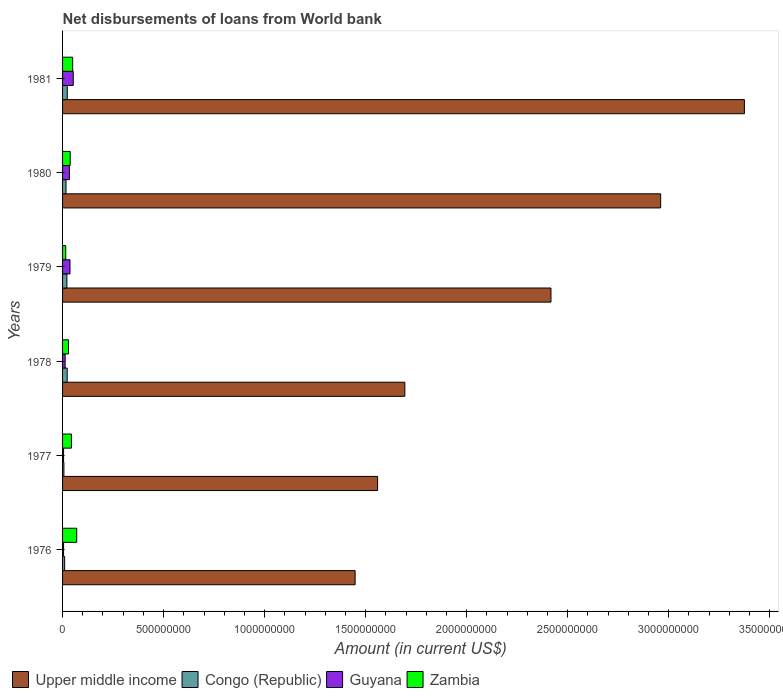How many different coloured bars are there?
Ensure brevity in your answer.  4. How many groups of bars are there?
Offer a terse response. 6. Are the number of bars per tick equal to the number of legend labels?
Your response must be concise. Yes. Are the number of bars on each tick of the Y-axis equal?
Keep it short and to the point. Yes. How many bars are there on the 5th tick from the bottom?
Offer a terse response. 4. What is the label of the 2nd group of bars from the top?
Provide a short and direct response. 1980. In how many cases, is the number of bars for a given year not equal to the number of legend labels?
Provide a succinct answer. 0. What is the amount of loan disbursed from World Bank in Upper middle income in 1977?
Offer a very short reply. 1.56e+09. Across all years, what is the maximum amount of loan disbursed from World Bank in Upper middle income?
Give a very brief answer. 3.37e+09. Across all years, what is the minimum amount of loan disbursed from World Bank in Zambia?
Your answer should be very brief. 1.57e+07. In which year was the amount of loan disbursed from World Bank in Zambia minimum?
Your answer should be compact. 1979. What is the total amount of loan disbursed from World Bank in Guyana in the graph?
Offer a very short reply. 1.46e+08. What is the difference between the amount of loan disbursed from World Bank in Upper middle income in 1976 and that in 1980?
Your answer should be very brief. -1.51e+09. What is the difference between the amount of loan disbursed from World Bank in Congo (Republic) in 1979 and the amount of loan disbursed from World Bank in Zambia in 1978?
Keep it short and to the point. -7.86e+06. What is the average amount of loan disbursed from World Bank in Zambia per year?
Keep it short and to the point. 4.11e+07. In the year 1978, what is the difference between the amount of loan disbursed from World Bank in Congo (Republic) and amount of loan disbursed from World Bank in Upper middle income?
Your answer should be very brief. -1.67e+09. In how many years, is the amount of loan disbursed from World Bank in Zambia greater than 2200000000 US$?
Make the answer very short. 0. What is the ratio of the amount of loan disbursed from World Bank in Congo (Republic) in 1977 to that in 1980?
Keep it short and to the point. 0.39. What is the difference between the highest and the second highest amount of loan disbursed from World Bank in Zambia?
Offer a very short reply. 2.00e+07. What is the difference between the highest and the lowest amount of loan disbursed from World Bank in Congo (Republic)?
Make the answer very short. 1.67e+07. In how many years, is the amount of loan disbursed from World Bank in Guyana greater than the average amount of loan disbursed from World Bank in Guyana taken over all years?
Offer a terse response. 3. Is it the case that in every year, the sum of the amount of loan disbursed from World Bank in Congo (Republic) and amount of loan disbursed from World Bank in Upper middle income is greater than the sum of amount of loan disbursed from World Bank in Guyana and amount of loan disbursed from World Bank in Zambia?
Your answer should be compact. No. What does the 4th bar from the top in 1981 represents?
Provide a short and direct response. Upper middle income. What does the 3rd bar from the bottom in 1979 represents?
Keep it short and to the point. Guyana. Is it the case that in every year, the sum of the amount of loan disbursed from World Bank in Zambia and amount of loan disbursed from World Bank in Congo (Republic) is greater than the amount of loan disbursed from World Bank in Guyana?
Provide a succinct answer. Yes. Does the graph contain any zero values?
Provide a short and direct response. No. Does the graph contain grids?
Your answer should be very brief. No. What is the title of the graph?
Provide a succinct answer. Net disbursements of loans from World bank. Does "Low income" appear as one of the legend labels in the graph?
Keep it short and to the point. No. What is the Amount (in current US$) in Upper middle income in 1976?
Provide a succinct answer. 1.45e+09. What is the Amount (in current US$) of Congo (Republic) in 1976?
Provide a short and direct response. 1.02e+07. What is the Amount (in current US$) in Guyana in 1976?
Give a very brief answer. 5.01e+06. What is the Amount (in current US$) of Zambia in 1976?
Make the answer very short. 7.00e+07. What is the Amount (in current US$) in Upper middle income in 1977?
Give a very brief answer. 1.56e+09. What is the Amount (in current US$) of Congo (Republic) in 1977?
Give a very brief answer. 6.67e+06. What is the Amount (in current US$) of Guyana in 1977?
Make the answer very short. 5.03e+06. What is the Amount (in current US$) in Zambia in 1977?
Make the answer very short. 4.40e+07. What is the Amount (in current US$) in Upper middle income in 1978?
Make the answer very short. 1.69e+09. What is the Amount (in current US$) of Congo (Republic) in 1978?
Offer a very short reply. 2.30e+07. What is the Amount (in current US$) of Guyana in 1978?
Your response must be concise. 1.28e+07. What is the Amount (in current US$) of Zambia in 1978?
Give a very brief answer. 2.93e+07. What is the Amount (in current US$) of Upper middle income in 1979?
Your answer should be compact. 2.42e+09. What is the Amount (in current US$) in Congo (Republic) in 1979?
Your answer should be very brief. 2.14e+07. What is the Amount (in current US$) in Guyana in 1979?
Ensure brevity in your answer.  3.68e+07. What is the Amount (in current US$) in Zambia in 1979?
Offer a terse response. 1.57e+07. What is the Amount (in current US$) in Upper middle income in 1980?
Give a very brief answer. 2.96e+09. What is the Amount (in current US$) in Congo (Republic) in 1980?
Your answer should be very brief. 1.71e+07. What is the Amount (in current US$) of Guyana in 1980?
Your answer should be very brief. 3.38e+07. What is the Amount (in current US$) of Zambia in 1980?
Ensure brevity in your answer.  3.78e+07. What is the Amount (in current US$) in Upper middle income in 1981?
Offer a very short reply. 3.37e+09. What is the Amount (in current US$) in Congo (Republic) in 1981?
Your response must be concise. 2.34e+07. What is the Amount (in current US$) of Guyana in 1981?
Give a very brief answer. 5.28e+07. What is the Amount (in current US$) of Zambia in 1981?
Your response must be concise. 5.00e+07. Across all years, what is the maximum Amount (in current US$) of Upper middle income?
Ensure brevity in your answer.  3.37e+09. Across all years, what is the maximum Amount (in current US$) of Congo (Republic)?
Offer a terse response. 2.34e+07. Across all years, what is the maximum Amount (in current US$) of Guyana?
Your answer should be very brief. 5.28e+07. Across all years, what is the maximum Amount (in current US$) in Zambia?
Make the answer very short. 7.00e+07. Across all years, what is the minimum Amount (in current US$) in Upper middle income?
Your answer should be compact. 1.45e+09. Across all years, what is the minimum Amount (in current US$) of Congo (Republic)?
Ensure brevity in your answer.  6.67e+06. Across all years, what is the minimum Amount (in current US$) in Guyana?
Offer a very short reply. 5.01e+06. Across all years, what is the minimum Amount (in current US$) in Zambia?
Give a very brief answer. 1.57e+07. What is the total Amount (in current US$) of Upper middle income in the graph?
Keep it short and to the point. 1.35e+1. What is the total Amount (in current US$) in Congo (Republic) in the graph?
Provide a short and direct response. 1.02e+08. What is the total Amount (in current US$) of Guyana in the graph?
Your answer should be very brief. 1.46e+08. What is the total Amount (in current US$) of Zambia in the graph?
Offer a very short reply. 2.47e+08. What is the difference between the Amount (in current US$) in Upper middle income in 1976 and that in 1977?
Make the answer very short. -1.11e+08. What is the difference between the Amount (in current US$) of Congo (Republic) in 1976 and that in 1977?
Provide a short and direct response. 3.58e+06. What is the difference between the Amount (in current US$) in Guyana in 1976 and that in 1977?
Offer a very short reply. -1.40e+04. What is the difference between the Amount (in current US$) in Zambia in 1976 and that in 1977?
Offer a terse response. 2.61e+07. What is the difference between the Amount (in current US$) of Upper middle income in 1976 and that in 1978?
Offer a very short reply. -2.46e+08. What is the difference between the Amount (in current US$) in Congo (Republic) in 1976 and that in 1978?
Give a very brief answer. -1.27e+07. What is the difference between the Amount (in current US$) in Guyana in 1976 and that in 1978?
Provide a short and direct response. -7.83e+06. What is the difference between the Amount (in current US$) in Zambia in 1976 and that in 1978?
Your response must be concise. 4.07e+07. What is the difference between the Amount (in current US$) in Upper middle income in 1976 and that in 1979?
Make the answer very short. -9.69e+08. What is the difference between the Amount (in current US$) of Congo (Republic) in 1976 and that in 1979?
Provide a succinct answer. -1.12e+07. What is the difference between the Amount (in current US$) in Guyana in 1976 and that in 1979?
Give a very brief answer. -3.18e+07. What is the difference between the Amount (in current US$) of Zambia in 1976 and that in 1979?
Your answer should be very brief. 5.44e+07. What is the difference between the Amount (in current US$) of Upper middle income in 1976 and that in 1980?
Offer a very short reply. -1.51e+09. What is the difference between the Amount (in current US$) in Congo (Republic) in 1976 and that in 1980?
Offer a very short reply. -6.86e+06. What is the difference between the Amount (in current US$) of Guyana in 1976 and that in 1980?
Provide a short and direct response. -2.88e+07. What is the difference between the Amount (in current US$) in Zambia in 1976 and that in 1980?
Keep it short and to the point. 3.22e+07. What is the difference between the Amount (in current US$) of Upper middle income in 1976 and that in 1981?
Provide a short and direct response. -1.93e+09. What is the difference between the Amount (in current US$) of Congo (Republic) in 1976 and that in 1981?
Give a very brief answer. -1.31e+07. What is the difference between the Amount (in current US$) in Guyana in 1976 and that in 1981?
Your answer should be very brief. -4.78e+07. What is the difference between the Amount (in current US$) in Zambia in 1976 and that in 1981?
Provide a succinct answer. 2.00e+07. What is the difference between the Amount (in current US$) in Upper middle income in 1977 and that in 1978?
Ensure brevity in your answer.  -1.35e+08. What is the difference between the Amount (in current US$) of Congo (Republic) in 1977 and that in 1978?
Your answer should be compact. -1.63e+07. What is the difference between the Amount (in current US$) of Guyana in 1977 and that in 1978?
Make the answer very short. -7.82e+06. What is the difference between the Amount (in current US$) of Zambia in 1977 and that in 1978?
Keep it short and to the point. 1.47e+07. What is the difference between the Amount (in current US$) of Upper middle income in 1977 and that in 1979?
Ensure brevity in your answer.  -8.58e+08. What is the difference between the Amount (in current US$) in Congo (Republic) in 1977 and that in 1979?
Make the answer very short. -1.48e+07. What is the difference between the Amount (in current US$) in Guyana in 1977 and that in 1979?
Keep it short and to the point. -3.18e+07. What is the difference between the Amount (in current US$) of Zambia in 1977 and that in 1979?
Give a very brief answer. 2.83e+07. What is the difference between the Amount (in current US$) in Upper middle income in 1977 and that in 1980?
Keep it short and to the point. -1.40e+09. What is the difference between the Amount (in current US$) of Congo (Republic) in 1977 and that in 1980?
Offer a very short reply. -1.04e+07. What is the difference between the Amount (in current US$) of Guyana in 1977 and that in 1980?
Make the answer very short. -2.88e+07. What is the difference between the Amount (in current US$) of Zambia in 1977 and that in 1980?
Your response must be concise. 6.12e+06. What is the difference between the Amount (in current US$) in Upper middle income in 1977 and that in 1981?
Give a very brief answer. -1.82e+09. What is the difference between the Amount (in current US$) of Congo (Republic) in 1977 and that in 1981?
Your answer should be very brief. -1.67e+07. What is the difference between the Amount (in current US$) of Guyana in 1977 and that in 1981?
Keep it short and to the point. -4.78e+07. What is the difference between the Amount (in current US$) in Zambia in 1977 and that in 1981?
Your answer should be very brief. -6.10e+06. What is the difference between the Amount (in current US$) of Upper middle income in 1978 and that in 1979?
Provide a succinct answer. -7.23e+08. What is the difference between the Amount (in current US$) of Congo (Republic) in 1978 and that in 1979?
Ensure brevity in your answer.  1.52e+06. What is the difference between the Amount (in current US$) of Guyana in 1978 and that in 1979?
Offer a very short reply. -2.40e+07. What is the difference between the Amount (in current US$) of Zambia in 1978 and that in 1979?
Provide a succinct answer. 1.36e+07. What is the difference between the Amount (in current US$) in Upper middle income in 1978 and that in 1980?
Ensure brevity in your answer.  -1.27e+09. What is the difference between the Amount (in current US$) in Congo (Republic) in 1978 and that in 1980?
Make the answer very short. 5.85e+06. What is the difference between the Amount (in current US$) in Guyana in 1978 and that in 1980?
Your response must be concise. -2.10e+07. What is the difference between the Amount (in current US$) of Zambia in 1978 and that in 1980?
Offer a very short reply. -8.54e+06. What is the difference between the Amount (in current US$) of Upper middle income in 1978 and that in 1981?
Ensure brevity in your answer.  -1.68e+09. What is the difference between the Amount (in current US$) of Congo (Republic) in 1978 and that in 1981?
Make the answer very short. -3.97e+05. What is the difference between the Amount (in current US$) of Guyana in 1978 and that in 1981?
Your answer should be very brief. -4.00e+07. What is the difference between the Amount (in current US$) of Zambia in 1978 and that in 1981?
Provide a short and direct response. -2.07e+07. What is the difference between the Amount (in current US$) of Upper middle income in 1979 and that in 1980?
Keep it short and to the point. -5.43e+08. What is the difference between the Amount (in current US$) in Congo (Republic) in 1979 and that in 1980?
Offer a very short reply. 4.34e+06. What is the difference between the Amount (in current US$) of Guyana in 1979 and that in 1980?
Provide a short and direct response. 3.01e+06. What is the difference between the Amount (in current US$) of Zambia in 1979 and that in 1980?
Ensure brevity in your answer.  -2.22e+07. What is the difference between the Amount (in current US$) in Upper middle income in 1979 and that in 1981?
Ensure brevity in your answer.  -9.57e+08. What is the difference between the Amount (in current US$) in Congo (Republic) in 1979 and that in 1981?
Make the answer very short. -1.91e+06. What is the difference between the Amount (in current US$) of Guyana in 1979 and that in 1981?
Keep it short and to the point. -1.60e+07. What is the difference between the Amount (in current US$) of Zambia in 1979 and that in 1981?
Your answer should be compact. -3.44e+07. What is the difference between the Amount (in current US$) of Upper middle income in 1980 and that in 1981?
Give a very brief answer. -4.14e+08. What is the difference between the Amount (in current US$) of Congo (Republic) in 1980 and that in 1981?
Your answer should be very brief. -6.25e+06. What is the difference between the Amount (in current US$) of Guyana in 1980 and that in 1981?
Offer a very short reply. -1.90e+07. What is the difference between the Amount (in current US$) in Zambia in 1980 and that in 1981?
Provide a succinct answer. -1.22e+07. What is the difference between the Amount (in current US$) in Upper middle income in 1976 and the Amount (in current US$) in Congo (Republic) in 1977?
Ensure brevity in your answer.  1.44e+09. What is the difference between the Amount (in current US$) of Upper middle income in 1976 and the Amount (in current US$) of Guyana in 1977?
Offer a terse response. 1.44e+09. What is the difference between the Amount (in current US$) of Upper middle income in 1976 and the Amount (in current US$) of Zambia in 1977?
Offer a very short reply. 1.40e+09. What is the difference between the Amount (in current US$) of Congo (Republic) in 1976 and the Amount (in current US$) of Guyana in 1977?
Make the answer very short. 5.22e+06. What is the difference between the Amount (in current US$) in Congo (Republic) in 1976 and the Amount (in current US$) in Zambia in 1977?
Provide a short and direct response. -3.37e+07. What is the difference between the Amount (in current US$) of Guyana in 1976 and the Amount (in current US$) of Zambia in 1977?
Give a very brief answer. -3.89e+07. What is the difference between the Amount (in current US$) of Upper middle income in 1976 and the Amount (in current US$) of Congo (Republic) in 1978?
Your response must be concise. 1.42e+09. What is the difference between the Amount (in current US$) in Upper middle income in 1976 and the Amount (in current US$) in Guyana in 1978?
Offer a terse response. 1.43e+09. What is the difference between the Amount (in current US$) in Upper middle income in 1976 and the Amount (in current US$) in Zambia in 1978?
Offer a very short reply. 1.42e+09. What is the difference between the Amount (in current US$) in Congo (Republic) in 1976 and the Amount (in current US$) in Guyana in 1978?
Your response must be concise. -2.60e+06. What is the difference between the Amount (in current US$) of Congo (Republic) in 1976 and the Amount (in current US$) of Zambia in 1978?
Keep it short and to the point. -1.91e+07. What is the difference between the Amount (in current US$) of Guyana in 1976 and the Amount (in current US$) of Zambia in 1978?
Provide a succinct answer. -2.43e+07. What is the difference between the Amount (in current US$) of Upper middle income in 1976 and the Amount (in current US$) of Congo (Republic) in 1979?
Offer a terse response. 1.43e+09. What is the difference between the Amount (in current US$) in Upper middle income in 1976 and the Amount (in current US$) in Guyana in 1979?
Offer a very short reply. 1.41e+09. What is the difference between the Amount (in current US$) in Upper middle income in 1976 and the Amount (in current US$) in Zambia in 1979?
Your answer should be very brief. 1.43e+09. What is the difference between the Amount (in current US$) of Congo (Republic) in 1976 and the Amount (in current US$) of Guyana in 1979?
Offer a terse response. -2.66e+07. What is the difference between the Amount (in current US$) in Congo (Republic) in 1976 and the Amount (in current US$) in Zambia in 1979?
Ensure brevity in your answer.  -5.43e+06. What is the difference between the Amount (in current US$) of Guyana in 1976 and the Amount (in current US$) of Zambia in 1979?
Provide a short and direct response. -1.07e+07. What is the difference between the Amount (in current US$) in Upper middle income in 1976 and the Amount (in current US$) in Congo (Republic) in 1980?
Your answer should be compact. 1.43e+09. What is the difference between the Amount (in current US$) in Upper middle income in 1976 and the Amount (in current US$) in Guyana in 1980?
Offer a terse response. 1.41e+09. What is the difference between the Amount (in current US$) of Upper middle income in 1976 and the Amount (in current US$) of Zambia in 1980?
Offer a terse response. 1.41e+09. What is the difference between the Amount (in current US$) of Congo (Republic) in 1976 and the Amount (in current US$) of Guyana in 1980?
Your response must be concise. -2.36e+07. What is the difference between the Amount (in current US$) of Congo (Republic) in 1976 and the Amount (in current US$) of Zambia in 1980?
Provide a succinct answer. -2.76e+07. What is the difference between the Amount (in current US$) of Guyana in 1976 and the Amount (in current US$) of Zambia in 1980?
Offer a terse response. -3.28e+07. What is the difference between the Amount (in current US$) in Upper middle income in 1976 and the Amount (in current US$) in Congo (Republic) in 1981?
Offer a very short reply. 1.42e+09. What is the difference between the Amount (in current US$) in Upper middle income in 1976 and the Amount (in current US$) in Guyana in 1981?
Keep it short and to the point. 1.39e+09. What is the difference between the Amount (in current US$) of Upper middle income in 1976 and the Amount (in current US$) of Zambia in 1981?
Offer a very short reply. 1.40e+09. What is the difference between the Amount (in current US$) of Congo (Republic) in 1976 and the Amount (in current US$) of Guyana in 1981?
Ensure brevity in your answer.  -4.26e+07. What is the difference between the Amount (in current US$) in Congo (Republic) in 1976 and the Amount (in current US$) in Zambia in 1981?
Provide a succinct answer. -3.98e+07. What is the difference between the Amount (in current US$) in Guyana in 1976 and the Amount (in current US$) in Zambia in 1981?
Provide a succinct answer. -4.50e+07. What is the difference between the Amount (in current US$) of Upper middle income in 1977 and the Amount (in current US$) of Congo (Republic) in 1978?
Keep it short and to the point. 1.54e+09. What is the difference between the Amount (in current US$) in Upper middle income in 1977 and the Amount (in current US$) in Guyana in 1978?
Provide a short and direct response. 1.55e+09. What is the difference between the Amount (in current US$) in Upper middle income in 1977 and the Amount (in current US$) in Zambia in 1978?
Your answer should be very brief. 1.53e+09. What is the difference between the Amount (in current US$) in Congo (Republic) in 1977 and the Amount (in current US$) in Guyana in 1978?
Make the answer very short. -6.18e+06. What is the difference between the Amount (in current US$) in Congo (Republic) in 1977 and the Amount (in current US$) in Zambia in 1978?
Your response must be concise. -2.26e+07. What is the difference between the Amount (in current US$) of Guyana in 1977 and the Amount (in current US$) of Zambia in 1978?
Offer a terse response. -2.43e+07. What is the difference between the Amount (in current US$) of Upper middle income in 1977 and the Amount (in current US$) of Congo (Republic) in 1979?
Offer a terse response. 1.54e+09. What is the difference between the Amount (in current US$) of Upper middle income in 1977 and the Amount (in current US$) of Guyana in 1979?
Provide a short and direct response. 1.52e+09. What is the difference between the Amount (in current US$) in Upper middle income in 1977 and the Amount (in current US$) in Zambia in 1979?
Provide a succinct answer. 1.54e+09. What is the difference between the Amount (in current US$) of Congo (Republic) in 1977 and the Amount (in current US$) of Guyana in 1979?
Offer a terse response. -3.02e+07. What is the difference between the Amount (in current US$) of Congo (Republic) in 1977 and the Amount (in current US$) of Zambia in 1979?
Give a very brief answer. -9.01e+06. What is the difference between the Amount (in current US$) of Guyana in 1977 and the Amount (in current US$) of Zambia in 1979?
Make the answer very short. -1.06e+07. What is the difference between the Amount (in current US$) of Upper middle income in 1977 and the Amount (in current US$) of Congo (Republic) in 1980?
Your answer should be very brief. 1.54e+09. What is the difference between the Amount (in current US$) in Upper middle income in 1977 and the Amount (in current US$) in Guyana in 1980?
Offer a very short reply. 1.53e+09. What is the difference between the Amount (in current US$) in Upper middle income in 1977 and the Amount (in current US$) in Zambia in 1980?
Provide a succinct answer. 1.52e+09. What is the difference between the Amount (in current US$) in Congo (Republic) in 1977 and the Amount (in current US$) in Guyana in 1980?
Your response must be concise. -2.71e+07. What is the difference between the Amount (in current US$) of Congo (Republic) in 1977 and the Amount (in current US$) of Zambia in 1980?
Make the answer very short. -3.12e+07. What is the difference between the Amount (in current US$) of Guyana in 1977 and the Amount (in current US$) of Zambia in 1980?
Make the answer very short. -3.28e+07. What is the difference between the Amount (in current US$) in Upper middle income in 1977 and the Amount (in current US$) in Congo (Republic) in 1981?
Provide a succinct answer. 1.54e+09. What is the difference between the Amount (in current US$) in Upper middle income in 1977 and the Amount (in current US$) in Guyana in 1981?
Your answer should be compact. 1.51e+09. What is the difference between the Amount (in current US$) in Upper middle income in 1977 and the Amount (in current US$) in Zambia in 1981?
Your response must be concise. 1.51e+09. What is the difference between the Amount (in current US$) in Congo (Republic) in 1977 and the Amount (in current US$) in Guyana in 1981?
Provide a short and direct response. -4.62e+07. What is the difference between the Amount (in current US$) in Congo (Republic) in 1977 and the Amount (in current US$) in Zambia in 1981?
Provide a short and direct response. -4.34e+07. What is the difference between the Amount (in current US$) in Guyana in 1977 and the Amount (in current US$) in Zambia in 1981?
Your response must be concise. -4.50e+07. What is the difference between the Amount (in current US$) in Upper middle income in 1978 and the Amount (in current US$) in Congo (Republic) in 1979?
Provide a short and direct response. 1.67e+09. What is the difference between the Amount (in current US$) in Upper middle income in 1978 and the Amount (in current US$) in Guyana in 1979?
Your answer should be compact. 1.66e+09. What is the difference between the Amount (in current US$) of Upper middle income in 1978 and the Amount (in current US$) of Zambia in 1979?
Ensure brevity in your answer.  1.68e+09. What is the difference between the Amount (in current US$) in Congo (Republic) in 1978 and the Amount (in current US$) in Guyana in 1979?
Your response must be concise. -1.39e+07. What is the difference between the Amount (in current US$) of Congo (Republic) in 1978 and the Amount (in current US$) of Zambia in 1979?
Provide a succinct answer. 7.28e+06. What is the difference between the Amount (in current US$) of Guyana in 1978 and the Amount (in current US$) of Zambia in 1979?
Make the answer very short. -2.83e+06. What is the difference between the Amount (in current US$) of Upper middle income in 1978 and the Amount (in current US$) of Congo (Republic) in 1980?
Ensure brevity in your answer.  1.68e+09. What is the difference between the Amount (in current US$) in Upper middle income in 1978 and the Amount (in current US$) in Guyana in 1980?
Ensure brevity in your answer.  1.66e+09. What is the difference between the Amount (in current US$) in Upper middle income in 1978 and the Amount (in current US$) in Zambia in 1980?
Keep it short and to the point. 1.66e+09. What is the difference between the Amount (in current US$) of Congo (Republic) in 1978 and the Amount (in current US$) of Guyana in 1980?
Provide a succinct answer. -1.09e+07. What is the difference between the Amount (in current US$) of Congo (Republic) in 1978 and the Amount (in current US$) of Zambia in 1980?
Your answer should be compact. -1.49e+07. What is the difference between the Amount (in current US$) of Guyana in 1978 and the Amount (in current US$) of Zambia in 1980?
Ensure brevity in your answer.  -2.50e+07. What is the difference between the Amount (in current US$) of Upper middle income in 1978 and the Amount (in current US$) of Congo (Republic) in 1981?
Make the answer very short. 1.67e+09. What is the difference between the Amount (in current US$) in Upper middle income in 1978 and the Amount (in current US$) in Guyana in 1981?
Offer a very short reply. 1.64e+09. What is the difference between the Amount (in current US$) of Upper middle income in 1978 and the Amount (in current US$) of Zambia in 1981?
Your answer should be compact. 1.64e+09. What is the difference between the Amount (in current US$) in Congo (Republic) in 1978 and the Amount (in current US$) in Guyana in 1981?
Your response must be concise. -2.99e+07. What is the difference between the Amount (in current US$) of Congo (Republic) in 1978 and the Amount (in current US$) of Zambia in 1981?
Make the answer very short. -2.71e+07. What is the difference between the Amount (in current US$) of Guyana in 1978 and the Amount (in current US$) of Zambia in 1981?
Keep it short and to the point. -3.72e+07. What is the difference between the Amount (in current US$) of Upper middle income in 1979 and the Amount (in current US$) of Congo (Republic) in 1980?
Provide a succinct answer. 2.40e+09. What is the difference between the Amount (in current US$) in Upper middle income in 1979 and the Amount (in current US$) in Guyana in 1980?
Ensure brevity in your answer.  2.38e+09. What is the difference between the Amount (in current US$) of Upper middle income in 1979 and the Amount (in current US$) of Zambia in 1980?
Your response must be concise. 2.38e+09. What is the difference between the Amount (in current US$) of Congo (Republic) in 1979 and the Amount (in current US$) of Guyana in 1980?
Make the answer very short. -1.24e+07. What is the difference between the Amount (in current US$) of Congo (Republic) in 1979 and the Amount (in current US$) of Zambia in 1980?
Offer a terse response. -1.64e+07. What is the difference between the Amount (in current US$) of Guyana in 1979 and the Amount (in current US$) of Zambia in 1980?
Provide a succinct answer. -1.02e+06. What is the difference between the Amount (in current US$) of Upper middle income in 1979 and the Amount (in current US$) of Congo (Republic) in 1981?
Keep it short and to the point. 2.39e+09. What is the difference between the Amount (in current US$) in Upper middle income in 1979 and the Amount (in current US$) in Guyana in 1981?
Provide a succinct answer. 2.36e+09. What is the difference between the Amount (in current US$) in Upper middle income in 1979 and the Amount (in current US$) in Zambia in 1981?
Make the answer very short. 2.37e+09. What is the difference between the Amount (in current US$) in Congo (Republic) in 1979 and the Amount (in current US$) in Guyana in 1981?
Make the answer very short. -3.14e+07. What is the difference between the Amount (in current US$) of Congo (Republic) in 1979 and the Amount (in current US$) of Zambia in 1981?
Offer a terse response. -2.86e+07. What is the difference between the Amount (in current US$) in Guyana in 1979 and the Amount (in current US$) in Zambia in 1981?
Provide a short and direct response. -1.32e+07. What is the difference between the Amount (in current US$) in Upper middle income in 1980 and the Amount (in current US$) in Congo (Republic) in 1981?
Offer a terse response. 2.94e+09. What is the difference between the Amount (in current US$) in Upper middle income in 1980 and the Amount (in current US$) in Guyana in 1981?
Your response must be concise. 2.91e+09. What is the difference between the Amount (in current US$) of Upper middle income in 1980 and the Amount (in current US$) of Zambia in 1981?
Your answer should be compact. 2.91e+09. What is the difference between the Amount (in current US$) of Congo (Republic) in 1980 and the Amount (in current US$) of Guyana in 1981?
Your answer should be very brief. -3.57e+07. What is the difference between the Amount (in current US$) in Congo (Republic) in 1980 and the Amount (in current US$) in Zambia in 1981?
Provide a succinct answer. -3.29e+07. What is the difference between the Amount (in current US$) in Guyana in 1980 and the Amount (in current US$) in Zambia in 1981?
Your answer should be compact. -1.62e+07. What is the average Amount (in current US$) of Upper middle income per year?
Ensure brevity in your answer.  2.24e+09. What is the average Amount (in current US$) of Congo (Republic) per year?
Your answer should be very brief. 1.70e+07. What is the average Amount (in current US$) of Guyana per year?
Your response must be concise. 2.44e+07. What is the average Amount (in current US$) in Zambia per year?
Your answer should be very brief. 4.11e+07. In the year 1976, what is the difference between the Amount (in current US$) in Upper middle income and Amount (in current US$) in Congo (Republic)?
Offer a terse response. 1.44e+09. In the year 1976, what is the difference between the Amount (in current US$) in Upper middle income and Amount (in current US$) in Guyana?
Ensure brevity in your answer.  1.44e+09. In the year 1976, what is the difference between the Amount (in current US$) in Upper middle income and Amount (in current US$) in Zambia?
Your answer should be very brief. 1.38e+09. In the year 1976, what is the difference between the Amount (in current US$) in Congo (Republic) and Amount (in current US$) in Guyana?
Give a very brief answer. 5.23e+06. In the year 1976, what is the difference between the Amount (in current US$) of Congo (Republic) and Amount (in current US$) of Zambia?
Offer a terse response. -5.98e+07. In the year 1976, what is the difference between the Amount (in current US$) in Guyana and Amount (in current US$) in Zambia?
Your response must be concise. -6.50e+07. In the year 1977, what is the difference between the Amount (in current US$) in Upper middle income and Amount (in current US$) in Congo (Republic)?
Offer a terse response. 1.55e+09. In the year 1977, what is the difference between the Amount (in current US$) in Upper middle income and Amount (in current US$) in Guyana?
Your response must be concise. 1.55e+09. In the year 1977, what is the difference between the Amount (in current US$) in Upper middle income and Amount (in current US$) in Zambia?
Provide a succinct answer. 1.52e+09. In the year 1977, what is the difference between the Amount (in current US$) of Congo (Republic) and Amount (in current US$) of Guyana?
Give a very brief answer. 1.64e+06. In the year 1977, what is the difference between the Amount (in current US$) in Congo (Republic) and Amount (in current US$) in Zambia?
Keep it short and to the point. -3.73e+07. In the year 1977, what is the difference between the Amount (in current US$) in Guyana and Amount (in current US$) in Zambia?
Your answer should be very brief. -3.89e+07. In the year 1978, what is the difference between the Amount (in current US$) of Upper middle income and Amount (in current US$) of Congo (Republic)?
Your answer should be very brief. 1.67e+09. In the year 1978, what is the difference between the Amount (in current US$) in Upper middle income and Amount (in current US$) in Guyana?
Provide a short and direct response. 1.68e+09. In the year 1978, what is the difference between the Amount (in current US$) of Upper middle income and Amount (in current US$) of Zambia?
Your response must be concise. 1.66e+09. In the year 1978, what is the difference between the Amount (in current US$) of Congo (Republic) and Amount (in current US$) of Guyana?
Provide a short and direct response. 1.01e+07. In the year 1978, what is the difference between the Amount (in current US$) in Congo (Republic) and Amount (in current US$) in Zambia?
Give a very brief answer. -6.35e+06. In the year 1978, what is the difference between the Amount (in current US$) of Guyana and Amount (in current US$) of Zambia?
Provide a short and direct response. -1.65e+07. In the year 1979, what is the difference between the Amount (in current US$) of Upper middle income and Amount (in current US$) of Congo (Republic)?
Give a very brief answer. 2.40e+09. In the year 1979, what is the difference between the Amount (in current US$) of Upper middle income and Amount (in current US$) of Guyana?
Ensure brevity in your answer.  2.38e+09. In the year 1979, what is the difference between the Amount (in current US$) of Upper middle income and Amount (in current US$) of Zambia?
Offer a very short reply. 2.40e+09. In the year 1979, what is the difference between the Amount (in current US$) in Congo (Republic) and Amount (in current US$) in Guyana?
Offer a very short reply. -1.54e+07. In the year 1979, what is the difference between the Amount (in current US$) in Congo (Republic) and Amount (in current US$) in Zambia?
Provide a short and direct response. 5.76e+06. In the year 1979, what is the difference between the Amount (in current US$) of Guyana and Amount (in current US$) of Zambia?
Offer a very short reply. 2.11e+07. In the year 1980, what is the difference between the Amount (in current US$) in Upper middle income and Amount (in current US$) in Congo (Republic)?
Ensure brevity in your answer.  2.94e+09. In the year 1980, what is the difference between the Amount (in current US$) in Upper middle income and Amount (in current US$) in Guyana?
Give a very brief answer. 2.93e+09. In the year 1980, what is the difference between the Amount (in current US$) in Upper middle income and Amount (in current US$) in Zambia?
Offer a terse response. 2.92e+09. In the year 1980, what is the difference between the Amount (in current US$) in Congo (Republic) and Amount (in current US$) in Guyana?
Your response must be concise. -1.67e+07. In the year 1980, what is the difference between the Amount (in current US$) in Congo (Republic) and Amount (in current US$) in Zambia?
Provide a succinct answer. -2.07e+07. In the year 1980, what is the difference between the Amount (in current US$) in Guyana and Amount (in current US$) in Zambia?
Your answer should be compact. -4.02e+06. In the year 1981, what is the difference between the Amount (in current US$) of Upper middle income and Amount (in current US$) of Congo (Republic)?
Your response must be concise. 3.35e+09. In the year 1981, what is the difference between the Amount (in current US$) of Upper middle income and Amount (in current US$) of Guyana?
Make the answer very short. 3.32e+09. In the year 1981, what is the difference between the Amount (in current US$) in Upper middle income and Amount (in current US$) in Zambia?
Offer a terse response. 3.32e+09. In the year 1981, what is the difference between the Amount (in current US$) in Congo (Republic) and Amount (in current US$) in Guyana?
Your response must be concise. -2.95e+07. In the year 1981, what is the difference between the Amount (in current US$) of Congo (Republic) and Amount (in current US$) of Zambia?
Provide a short and direct response. -2.67e+07. In the year 1981, what is the difference between the Amount (in current US$) of Guyana and Amount (in current US$) of Zambia?
Offer a terse response. 2.80e+06. What is the ratio of the Amount (in current US$) of Congo (Republic) in 1976 to that in 1977?
Your answer should be very brief. 1.54. What is the ratio of the Amount (in current US$) in Zambia in 1976 to that in 1977?
Offer a terse response. 1.59. What is the ratio of the Amount (in current US$) of Upper middle income in 1976 to that in 1978?
Make the answer very short. 0.85. What is the ratio of the Amount (in current US$) of Congo (Republic) in 1976 to that in 1978?
Your answer should be compact. 0.45. What is the ratio of the Amount (in current US$) in Guyana in 1976 to that in 1978?
Keep it short and to the point. 0.39. What is the ratio of the Amount (in current US$) of Zambia in 1976 to that in 1978?
Your answer should be very brief. 2.39. What is the ratio of the Amount (in current US$) of Upper middle income in 1976 to that in 1979?
Offer a terse response. 0.6. What is the ratio of the Amount (in current US$) in Congo (Republic) in 1976 to that in 1979?
Provide a succinct answer. 0.48. What is the ratio of the Amount (in current US$) in Guyana in 1976 to that in 1979?
Give a very brief answer. 0.14. What is the ratio of the Amount (in current US$) of Zambia in 1976 to that in 1979?
Give a very brief answer. 4.47. What is the ratio of the Amount (in current US$) of Upper middle income in 1976 to that in 1980?
Offer a very short reply. 0.49. What is the ratio of the Amount (in current US$) in Congo (Republic) in 1976 to that in 1980?
Offer a very short reply. 0.6. What is the ratio of the Amount (in current US$) of Guyana in 1976 to that in 1980?
Make the answer very short. 0.15. What is the ratio of the Amount (in current US$) of Zambia in 1976 to that in 1980?
Offer a terse response. 1.85. What is the ratio of the Amount (in current US$) of Upper middle income in 1976 to that in 1981?
Offer a very short reply. 0.43. What is the ratio of the Amount (in current US$) of Congo (Republic) in 1976 to that in 1981?
Give a very brief answer. 0.44. What is the ratio of the Amount (in current US$) of Guyana in 1976 to that in 1981?
Ensure brevity in your answer.  0.09. What is the ratio of the Amount (in current US$) of Zambia in 1976 to that in 1981?
Give a very brief answer. 1.4. What is the ratio of the Amount (in current US$) in Upper middle income in 1977 to that in 1978?
Your response must be concise. 0.92. What is the ratio of the Amount (in current US$) in Congo (Republic) in 1977 to that in 1978?
Keep it short and to the point. 0.29. What is the ratio of the Amount (in current US$) in Guyana in 1977 to that in 1978?
Offer a terse response. 0.39. What is the ratio of the Amount (in current US$) in Zambia in 1977 to that in 1978?
Provide a succinct answer. 1.5. What is the ratio of the Amount (in current US$) of Upper middle income in 1977 to that in 1979?
Provide a succinct answer. 0.65. What is the ratio of the Amount (in current US$) in Congo (Republic) in 1977 to that in 1979?
Offer a very short reply. 0.31. What is the ratio of the Amount (in current US$) of Guyana in 1977 to that in 1979?
Offer a terse response. 0.14. What is the ratio of the Amount (in current US$) in Zambia in 1977 to that in 1979?
Make the answer very short. 2.8. What is the ratio of the Amount (in current US$) in Upper middle income in 1977 to that in 1980?
Your response must be concise. 0.53. What is the ratio of the Amount (in current US$) in Congo (Republic) in 1977 to that in 1980?
Give a very brief answer. 0.39. What is the ratio of the Amount (in current US$) of Guyana in 1977 to that in 1980?
Your answer should be compact. 0.15. What is the ratio of the Amount (in current US$) of Zambia in 1977 to that in 1980?
Provide a short and direct response. 1.16. What is the ratio of the Amount (in current US$) of Upper middle income in 1977 to that in 1981?
Provide a succinct answer. 0.46. What is the ratio of the Amount (in current US$) of Congo (Republic) in 1977 to that in 1981?
Your response must be concise. 0.29. What is the ratio of the Amount (in current US$) in Guyana in 1977 to that in 1981?
Offer a very short reply. 0.1. What is the ratio of the Amount (in current US$) in Zambia in 1977 to that in 1981?
Your response must be concise. 0.88. What is the ratio of the Amount (in current US$) in Upper middle income in 1978 to that in 1979?
Provide a short and direct response. 0.7. What is the ratio of the Amount (in current US$) of Congo (Republic) in 1978 to that in 1979?
Give a very brief answer. 1.07. What is the ratio of the Amount (in current US$) in Guyana in 1978 to that in 1979?
Offer a very short reply. 0.35. What is the ratio of the Amount (in current US$) of Zambia in 1978 to that in 1979?
Offer a very short reply. 1.87. What is the ratio of the Amount (in current US$) of Upper middle income in 1978 to that in 1980?
Your answer should be very brief. 0.57. What is the ratio of the Amount (in current US$) of Congo (Republic) in 1978 to that in 1980?
Your answer should be very brief. 1.34. What is the ratio of the Amount (in current US$) in Guyana in 1978 to that in 1980?
Your response must be concise. 0.38. What is the ratio of the Amount (in current US$) of Zambia in 1978 to that in 1980?
Ensure brevity in your answer.  0.77. What is the ratio of the Amount (in current US$) of Upper middle income in 1978 to that in 1981?
Give a very brief answer. 0.5. What is the ratio of the Amount (in current US$) of Guyana in 1978 to that in 1981?
Your answer should be very brief. 0.24. What is the ratio of the Amount (in current US$) of Zambia in 1978 to that in 1981?
Your answer should be compact. 0.59. What is the ratio of the Amount (in current US$) of Upper middle income in 1979 to that in 1980?
Provide a succinct answer. 0.82. What is the ratio of the Amount (in current US$) in Congo (Republic) in 1979 to that in 1980?
Ensure brevity in your answer.  1.25. What is the ratio of the Amount (in current US$) in Guyana in 1979 to that in 1980?
Your answer should be very brief. 1.09. What is the ratio of the Amount (in current US$) in Zambia in 1979 to that in 1980?
Your answer should be very brief. 0.41. What is the ratio of the Amount (in current US$) of Upper middle income in 1979 to that in 1981?
Your answer should be compact. 0.72. What is the ratio of the Amount (in current US$) in Congo (Republic) in 1979 to that in 1981?
Make the answer very short. 0.92. What is the ratio of the Amount (in current US$) of Guyana in 1979 to that in 1981?
Provide a succinct answer. 0.7. What is the ratio of the Amount (in current US$) in Zambia in 1979 to that in 1981?
Offer a terse response. 0.31. What is the ratio of the Amount (in current US$) of Upper middle income in 1980 to that in 1981?
Your answer should be compact. 0.88. What is the ratio of the Amount (in current US$) in Congo (Republic) in 1980 to that in 1981?
Give a very brief answer. 0.73. What is the ratio of the Amount (in current US$) in Guyana in 1980 to that in 1981?
Offer a terse response. 0.64. What is the ratio of the Amount (in current US$) of Zambia in 1980 to that in 1981?
Provide a succinct answer. 0.76. What is the difference between the highest and the second highest Amount (in current US$) of Upper middle income?
Make the answer very short. 4.14e+08. What is the difference between the highest and the second highest Amount (in current US$) of Congo (Republic)?
Give a very brief answer. 3.97e+05. What is the difference between the highest and the second highest Amount (in current US$) in Guyana?
Offer a terse response. 1.60e+07. What is the difference between the highest and the second highest Amount (in current US$) in Zambia?
Your response must be concise. 2.00e+07. What is the difference between the highest and the lowest Amount (in current US$) of Upper middle income?
Provide a short and direct response. 1.93e+09. What is the difference between the highest and the lowest Amount (in current US$) of Congo (Republic)?
Ensure brevity in your answer.  1.67e+07. What is the difference between the highest and the lowest Amount (in current US$) of Guyana?
Your answer should be very brief. 4.78e+07. What is the difference between the highest and the lowest Amount (in current US$) in Zambia?
Your response must be concise. 5.44e+07. 